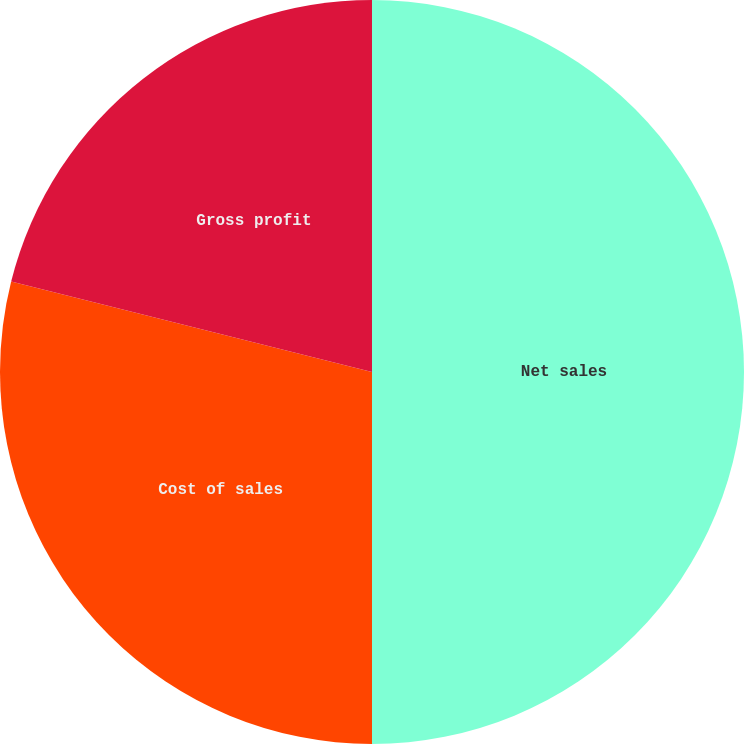Convert chart. <chart><loc_0><loc_0><loc_500><loc_500><pie_chart><fcel>Net sales<fcel>Cost of sales<fcel>Gross profit<nl><fcel>50.0%<fcel>28.91%<fcel>21.09%<nl></chart> 